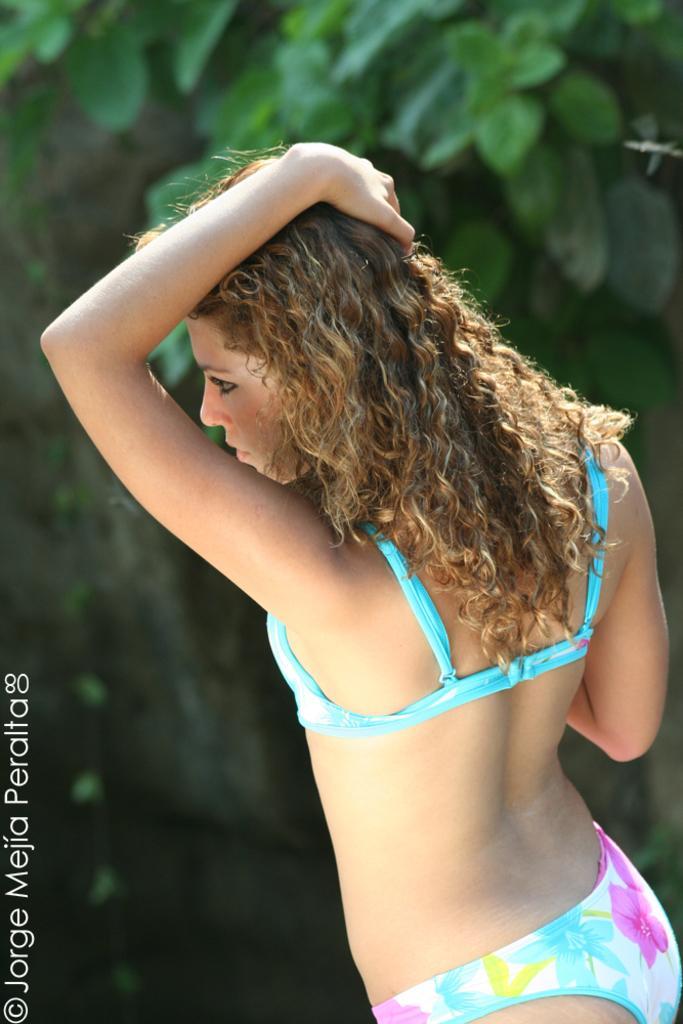Could you give a brief overview of what you see in this image? In the middle of this image, there is a woman, placing a hand on her head and watching something. On the bottom left, there is a watermark. In the background, there are trees. 